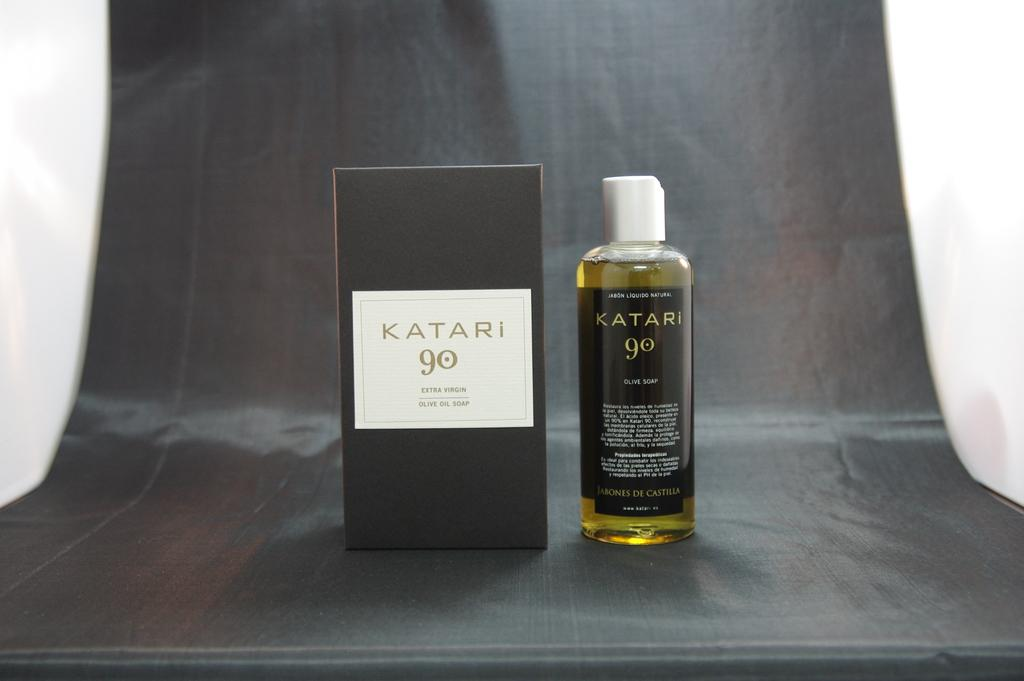Provide a one-sentence caption for the provided image. a bottle of liquid soap made from olive oil named katari go. 